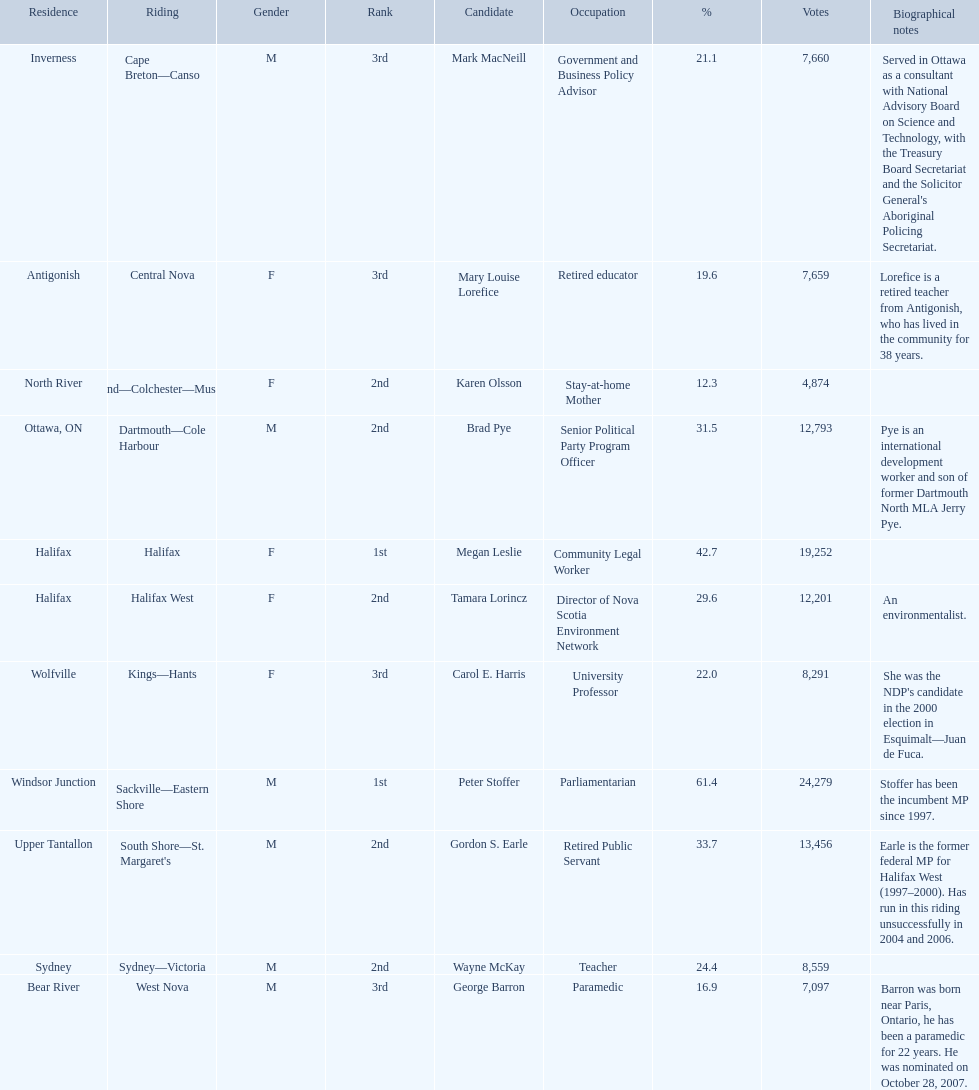What new democratic party candidates ran in the 2008 canadian federal election? Mark MacNeill, Mary Louise Lorefice, Karen Olsson, Brad Pye, Megan Leslie, Tamara Lorincz, Carol E. Harris, Peter Stoffer, Gordon S. Earle, Wayne McKay, George Barron. Of these candidates, which are female? Mary Louise Lorefice, Karen Olsson, Megan Leslie, Tamara Lorincz, Carol E. Harris. Which of these candidates resides in halifax? Megan Leslie, Tamara Lorincz. Of the remaining two, which was ranked 1st? Megan Leslie. How many votes did she get? 19,252. 